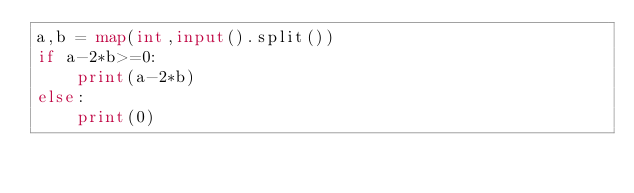Convert code to text. <code><loc_0><loc_0><loc_500><loc_500><_Python_>a,b = map(int,input().split())
if a-2*b>=0:
    print(a-2*b)
else:
    print(0)</code> 